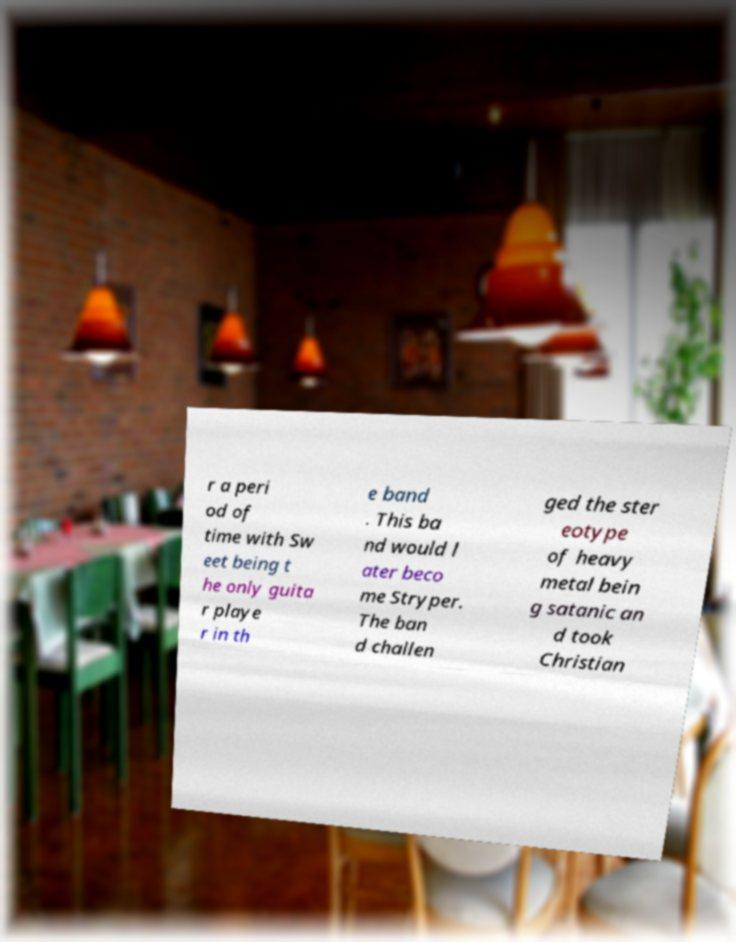Please read and relay the text visible in this image. What does it say? r a peri od of time with Sw eet being t he only guita r playe r in th e band . This ba nd would l ater beco me Stryper. The ban d challen ged the ster eotype of heavy metal bein g satanic an d took Christian 